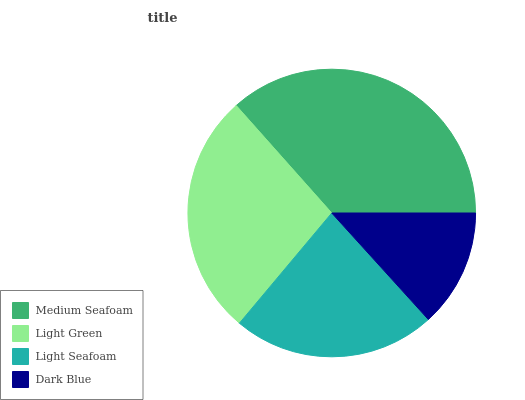Is Dark Blue the minimum?
Answer yes or no. Yes. Is Medium Seafoam the maximum?
Answer yes or no. Yes. Is Light Green the minimum?
Answer yes or no. No. Is Light Green the maximum?
Answer yes or no. No. Is Medium Seafoam greater than Light Green?
Answer yes or no. Yes. Is Light Green less than Medium Seafoam?
Answer yes or no. Yes. Is Light Green greater than Medium Seafoam?
Answer yes or no. No. Is Medium Seafoam less than Light Green?
Answer yes or no. No. Is Light Green the high median?
Answer yes or no. Yes. Is Light Seafoam the low median?
Answer yes or no. Yes. Is Light Seafoam the high median?
Answer yes or no. No. Is Medium Seafoam the low median?
Answer yes or no. No. 